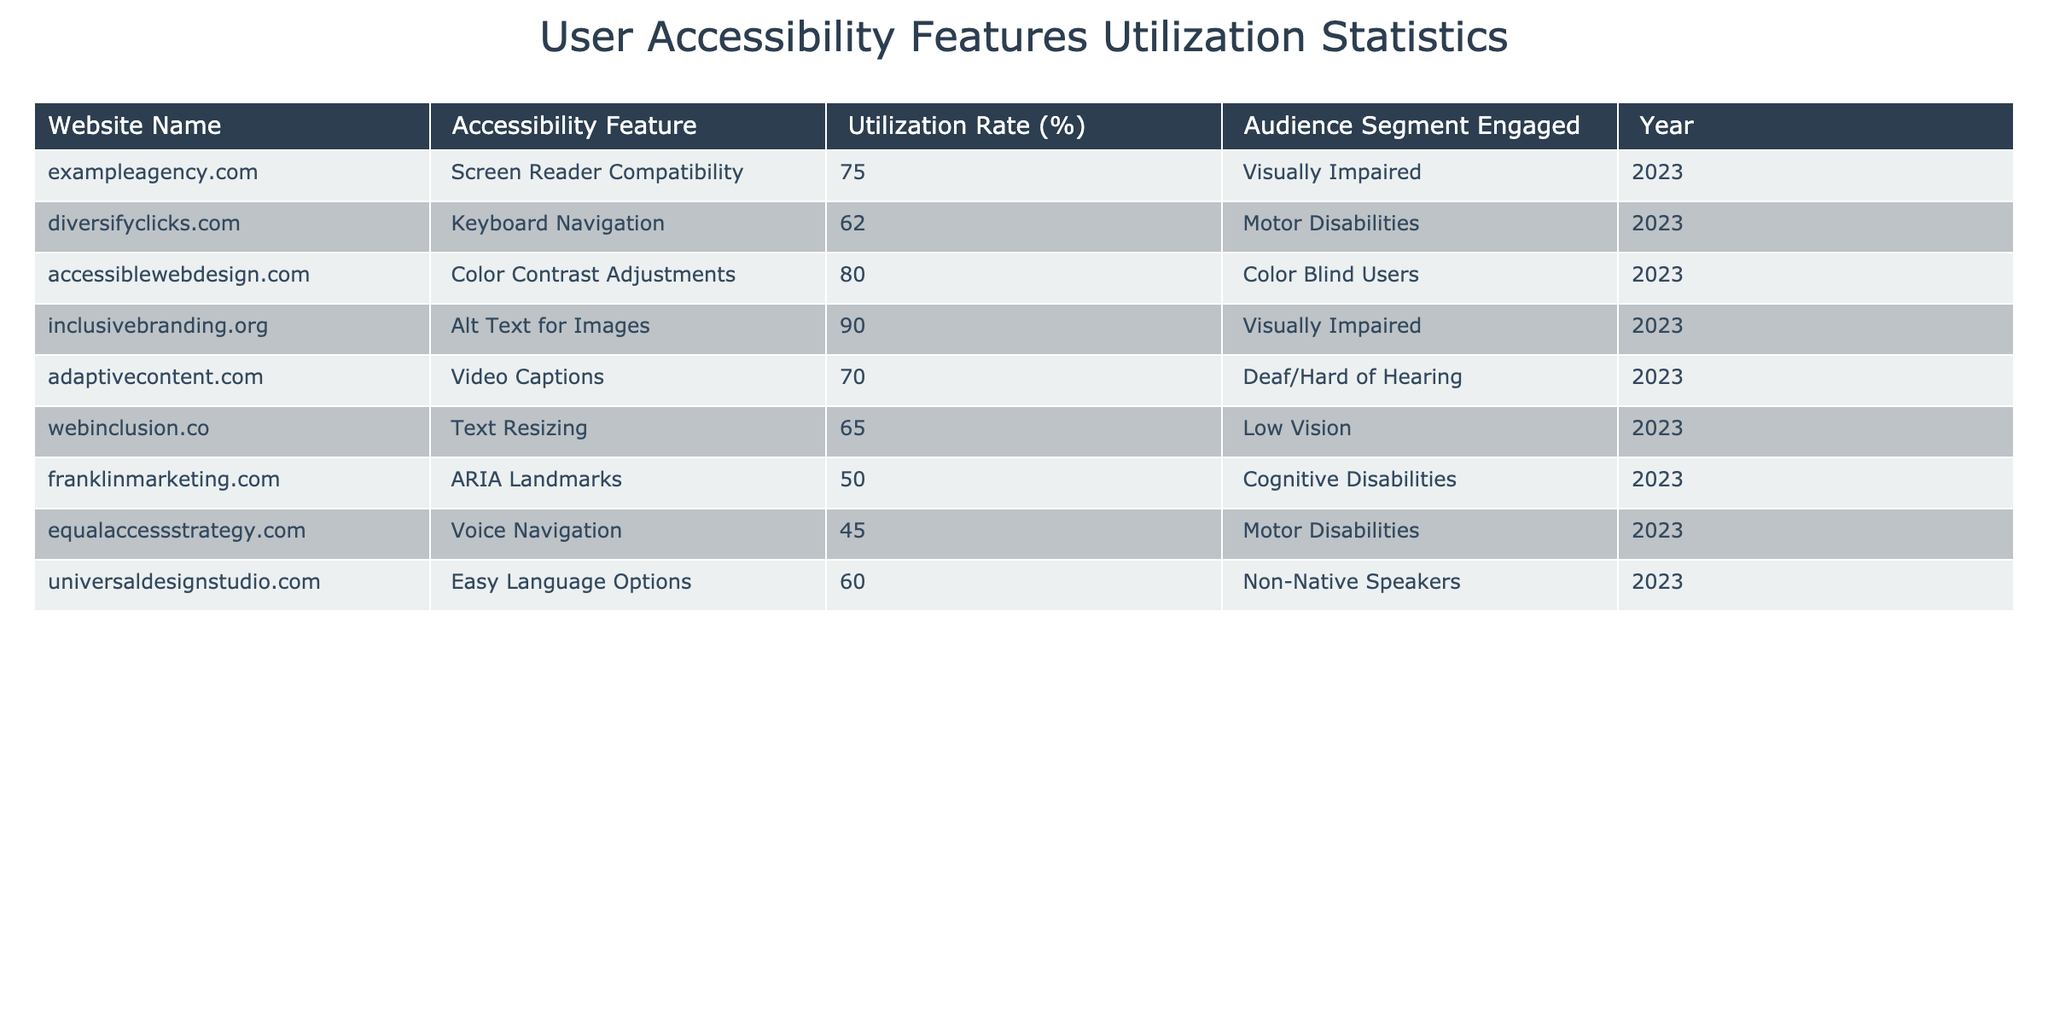What is the highest utilization rate for an accessibility feature? The table lists the utilization rates for all accessibility features. By reviewing the percentages, the highest rate is 90% for "Alt Text for Images" on the website inclusivebranding.org.
Answer: 90% Which website has the lowest utilization rate? The table indicates that "Voice Navigation" on equalaccessstrategy.com has the lowest utilization rate, at 45%.
Answer: 45% What is the average utilization rate across all accessibility features? To find the average, all the utilization rates need to be summed: 75 + 62 + 80 + 90 + 70 + 65 + 50 + 45 + 60 =  752. Then divide by the number of features (9), resulting in an average of 752/9 = approximately 83.56.
Answer: 83.56% Is there a website that provides both keyboard navigation and video captions? By checking the table, diversifyclicks.com offers keyboard navigation and adaptivecontent.com provides video captions. However, they are separate websites, so the answer is no, there is no single website providing both features.
Answer: No How many features have a utilization rate above 70%? The features with rates above 70% are Screen Reader Compatibility (75%), Color Contrast Adjustments (80%), Alt Text for Images (90%), and Video Captions (70%). Counting these, there are 4 features above 70%.
Answer: 4 What percentage difference is there between the usage of ARIA Landmarks and Alt Text for Images? To find the percentage difference, subtract the utilization rate of ARIA Landmarks (50%) from Alt Text for Images (90%): 90% - 50% = 40%. Thus, there is a 40% difference between these two features.
Answer: 40% Which audience segment is engaged the most based on the utilization rates? By looking at the utilization rates, the audience segment with the highest engagement is "Visually Impaired" with two features (Screen Reader Compatibility and Alt Text for Images) having high rates (75% and 90%). Therefore, Visually Impaired engages the most audiences overall, based on features utilized.
Answer: Visually Impaired What feature has a utilization rate of 62%? Checking the table, "Keyboard Navigation" on diversifyclicks.com has a utilization rate of 62%.
Answer: 62% Is the utilization rate for "Easy Language Options" higher than that for "Voice Navigation"? The utilization rate for "Easy Language Options" (60%) is compared to that for "Voice Navigation" (45%). Since 60% is greater than 45%, the answer is yes.
Answer: Yes 